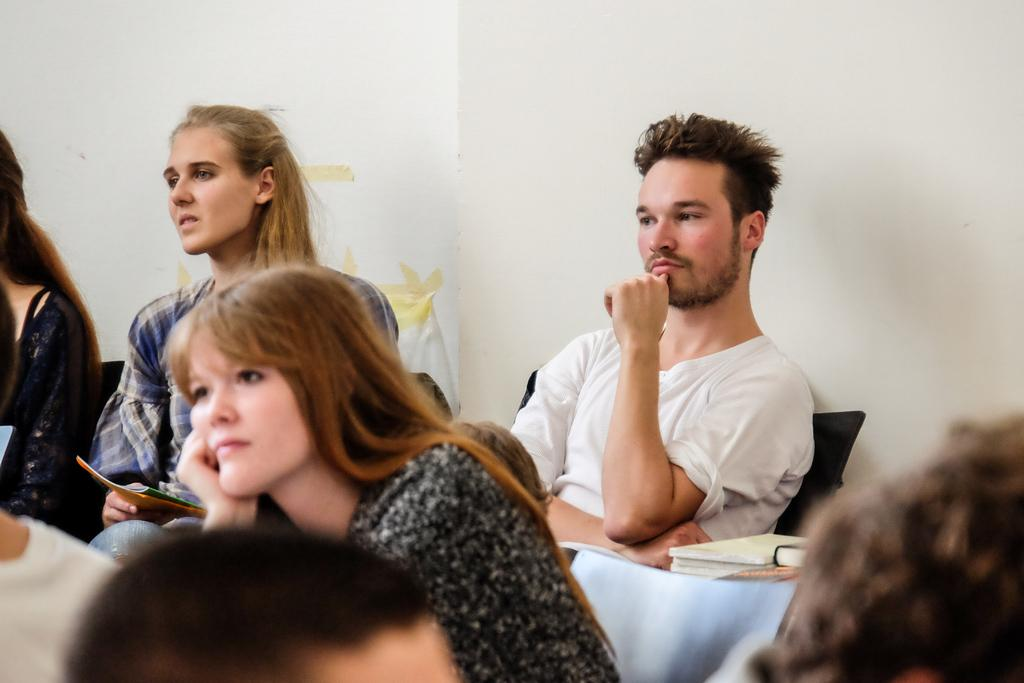Where was the image taken? The image was taken indoors. What can be seen in the background of the image? There is a wall in the background of the image. What are the people in the image doing? The people in the image are sitting on chairs. What objects are on the table in the image? There are books on a table in the image. What type of knife is being used by the person in the image? There is no knife present in the image. What time of day is it in the image? The time of day cannot be determined from the image, as there are no clues to suggest morning or any other time. 